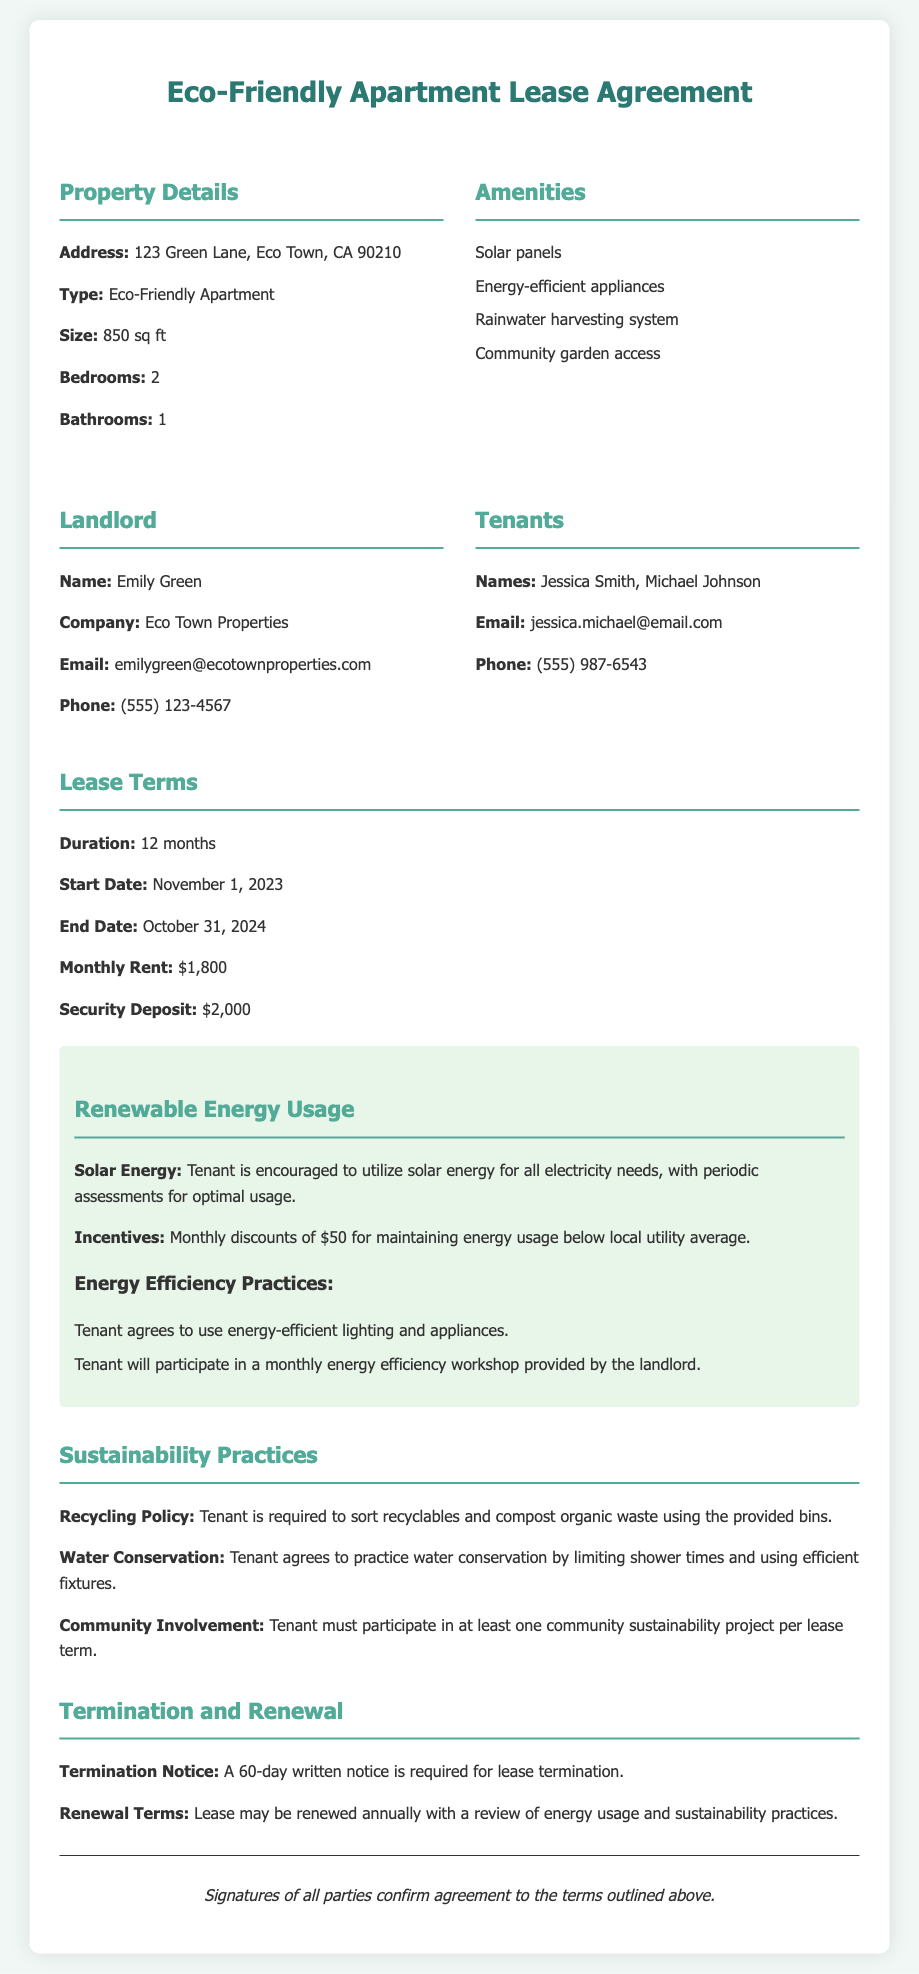What is the address of the apartment? The address of the apartment is listed in the Property Details section.
Answer: 123 Green Lane, Eco Town, CA 90210 Who is the landlord? The landlord's name is mentioned in the parties section of the document.
Answer: Emily Green What is the monthly rent? The monthly rent is specified in the Lease Terms section.
Answer: $1,800 What is the security deposit amount? The security deposit amount can be found in the Lease Terms section.
Answer: $2,000 What are the incentives for maintaining low energy usage? The incentives are mentioned under Renewable Energy Usage.
Answer: Monthly discounts of $50 How long is the lease duration? The lease duration is provided in the Lease Terms section.
Answer: 12 months What is a requirement for tenants regarding community involvement? The requirement is found in the Sustainability Practices section.
Answer: Participate in at least one community sustainability project How much notice is needed to terminate the lease? The notice period is specified in the Termination and Renewal section.
Answer: 60-day written notice What energy efficiency practices must tenants agree to? The practices are listed under Renewable Energy Usage.
Answer: Use energy-efficient lighting and appliances 